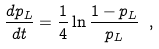<formula> <loc_0><loc_0><loc_500><loc_500>\frac { d p _ { L } } { d t } = \frac { 1 } { 4 } \ln \frac { 1 - p _ { L } } { p _ { L } } \ ,</formula> 